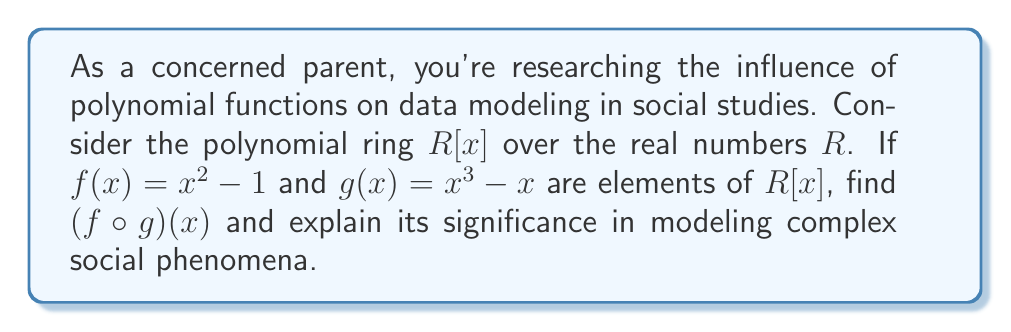Can you answer this question? Let's approach this step-by-step:

1) First, we need to understand what $(f \circ g)(x)$ means. It's the composition of $f$ and $g$, where we apply $g$ first, then $f$.

2) We start with $g(x) = x^3 - x$

3) Now, we need to substitute this entire expression for $x$ in $f(x)$:

   $f(g(x)) = (x^3 - x)^2 - 1$

4) Let's expand this:
   
   $(x^3 - x)^2 - 1 = (x^3 - x)(x^3 - x) - 1$
   
   $= x^6 - x^4 - x^4 + x^2 - 1$
   
   $= x^6 - 2x^4 + x^2 - 1$

5) Therefore, $(f \circ g)(x) = x^6 - 2x^4 + x^2 - 1$

This result demonstrates how simple polynomials can combine to create more complex functions. In social studies, such composite functions can model intricate relationships between variables, helping to describe and predict complex social phenomena. The higher degree of the resulting polynomial (6th degree) suggests it can capture more nuanced patterns than either of the original functions alone.
Answer: $(f \circ g)(x) = x^6 - 2x^4 + x^2 - 1$ 